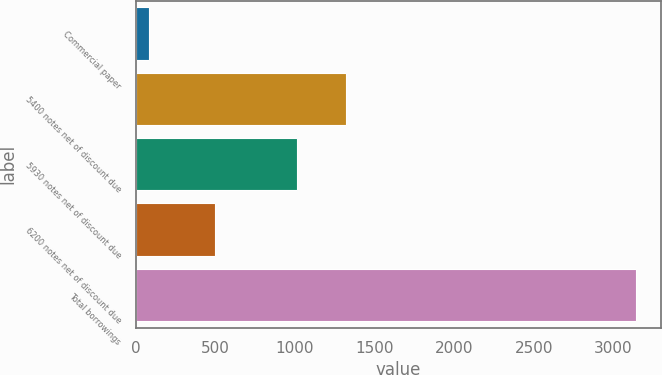Convert chart. <chart><loc_0><loc_0><loc_500><loc_500><bar_chart><fcel>Commercial paper<fcel>5400 notes net of discount due<fcel>5930 notes net of discount due<fcel>6200 notes net of discount due<fcel>Total borrowings<nl><fcel>82.9<fcel>1320.46<fcel>1014.4<fcel>497.4<fcel>3143.5<nl></chart> 